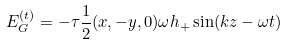<formula> <loc_0><loc_0><loc_500><loc_500>E _ { G } ^ { ( t ) } = - \tau \frac { 1 } { 2 } ( x , - y , 0 ) \omega h _ { + } \sin ( k z - \omega t )</formula> 